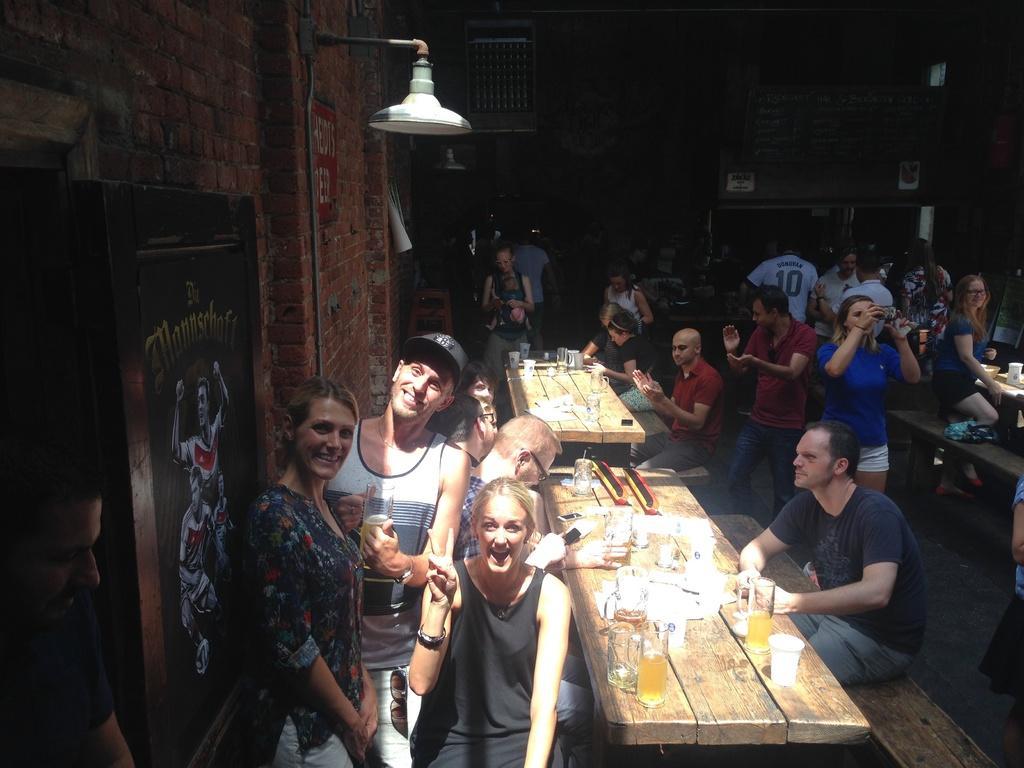Can you describe this image briefly? There are few people standing and few people sitting on the bench. These are the tables. I can see glasses,jugs placed on the table. This is the wooden photo frame and lamp attached to the wall. At the background I can see a board with something written on it. This looks like a poster attached to the wall. 